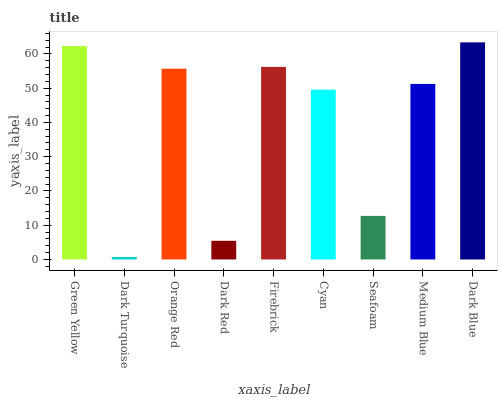Is Dark Turquoise the minimum?
Answer yes or no. Yes. Is Dark Blue the maximum?
Answer yes or no. Yes. Is Orange Red the minimum?
Answer yes or no. No. Is Orange Red the maximum?
Answer yes or no. No. Is Orange Red greater than Dark Turquoise?
Answer yes or no. Yes. Is Dark Turquoise less than Orange Red?
Answer yes or no. Yes. Is Dark Turquoise greater than Orange Red?
Answer yes or no. No. Is Orange Red less than Dark Turquoise?
Answer yes or no. No. Is Medium Blue the high median?
Answer yes or no. Yes. Is Medium Blue the low median?
Answer yes or no. Yes. Is Green Yellow the high median?
Answer yes or no. No. Is Dark Turquoise the low median?
Answer yes or no. No. 